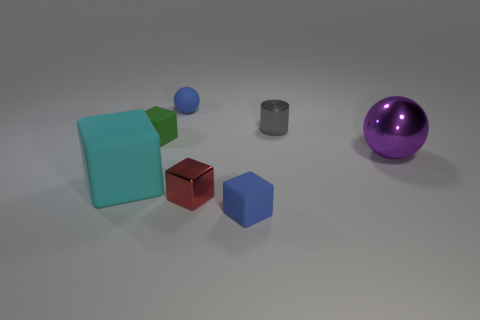The tiny object that is the same color as the tiny sphere is what shape?
Your response must be concise. Cube. There is a cube that is both to the left of the blue block and in front of the big cyan object; what color is it?
Ensure brevity in your answer.  Red. How many metal cylinders are right of the big thing that is to the left of the purple ball?
Offer a terse response. 1. Are there any red objects of the same shape as the small green object?
Make the answer very short. Yes. What color is the small object that is to the left of the sphere behind the purple ball?
Provide a succinct answer. Green. Are there more matte blocks than small green blocks?
Offer a terse response. Yes. What number of blue matte spheres have the same size as the gray shiny object?
Your answer should be very brief. 1. Is the small gray thing made of the same material as the sphere behind the purple object?
Give a very brief answer. No. Is the number of red metallic objects less than the number of tiny blue things?
Your response must be concise. Yes. Are there any other things that have the same color as the tiny metal block?
Offer a very short reply. No. 